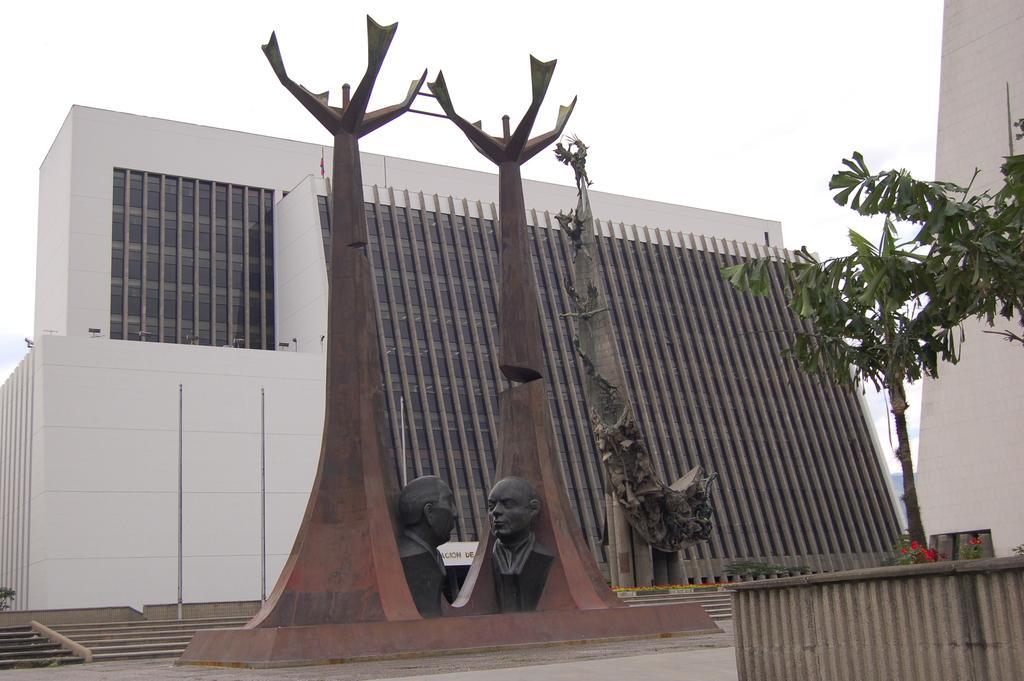In one or two sentences, can you explain what this image depicts? In this picture I can observe a building. I can observe three sculptures in the middle of the picture. On the right side there are plants. In the background there is sky. 